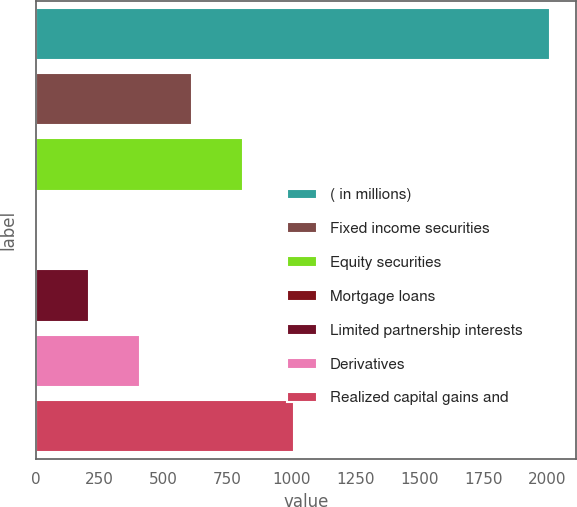Convert chart to OTSL. <chart><loc_0><loc_0><loc_500><loc_500><bar_chart><fcel>( in millions)<fcel>Fixed income securities<fcel>Equity securities<fcel>Mortgage loans<fcel>Limited partnership interests<fcel>Derivatives<fcel>Realized capital gains and<nl><fcel>2012<fcel>609.2<fcel>809.6<fcel>8<fcel>208.4<fcel>408.8<fcel>1010<nl></chart> 